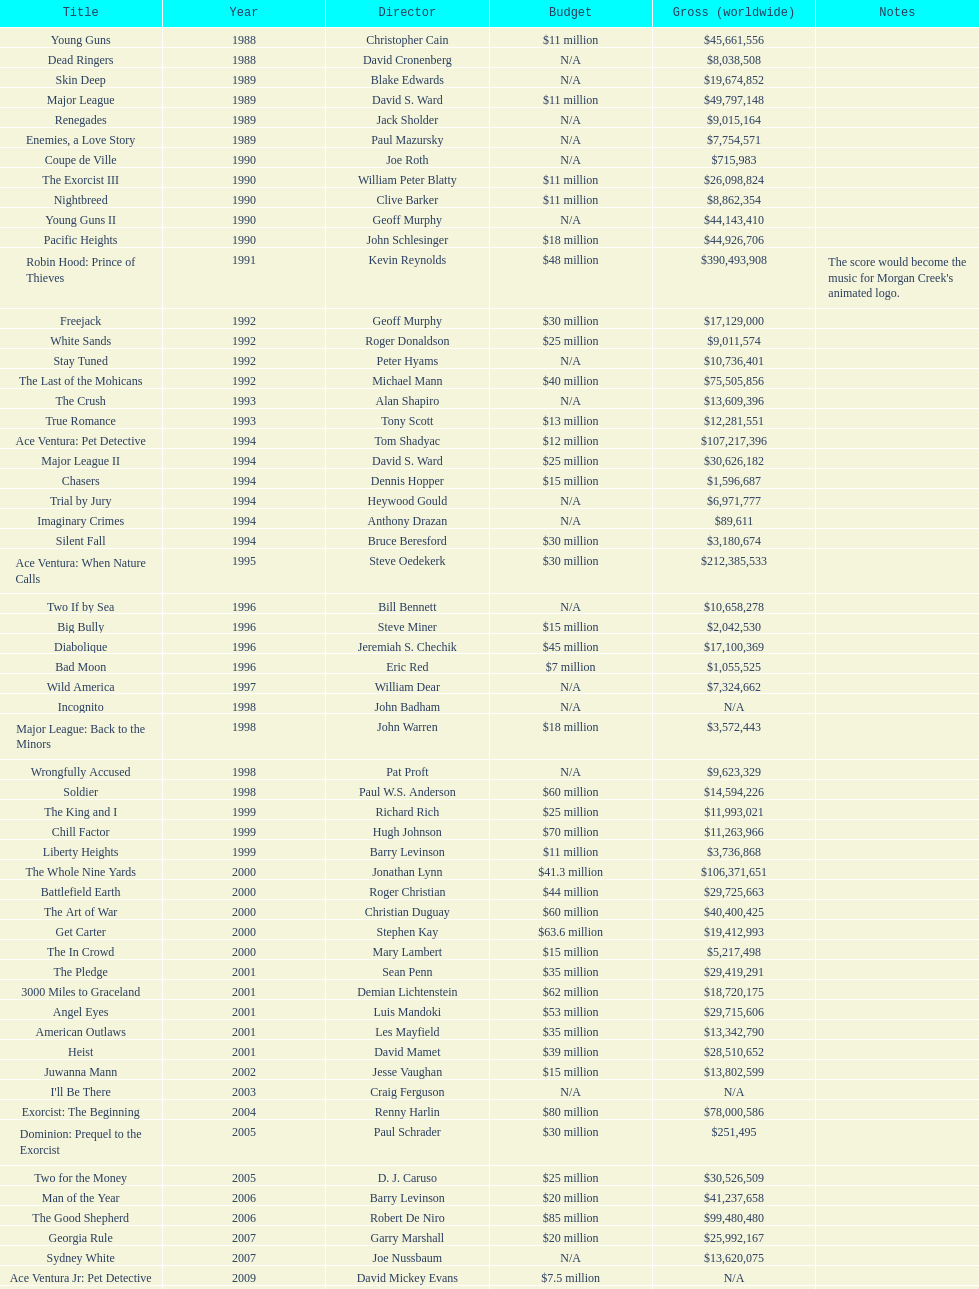Was the young guns budget higher or lower than freejack's budget? Less. 